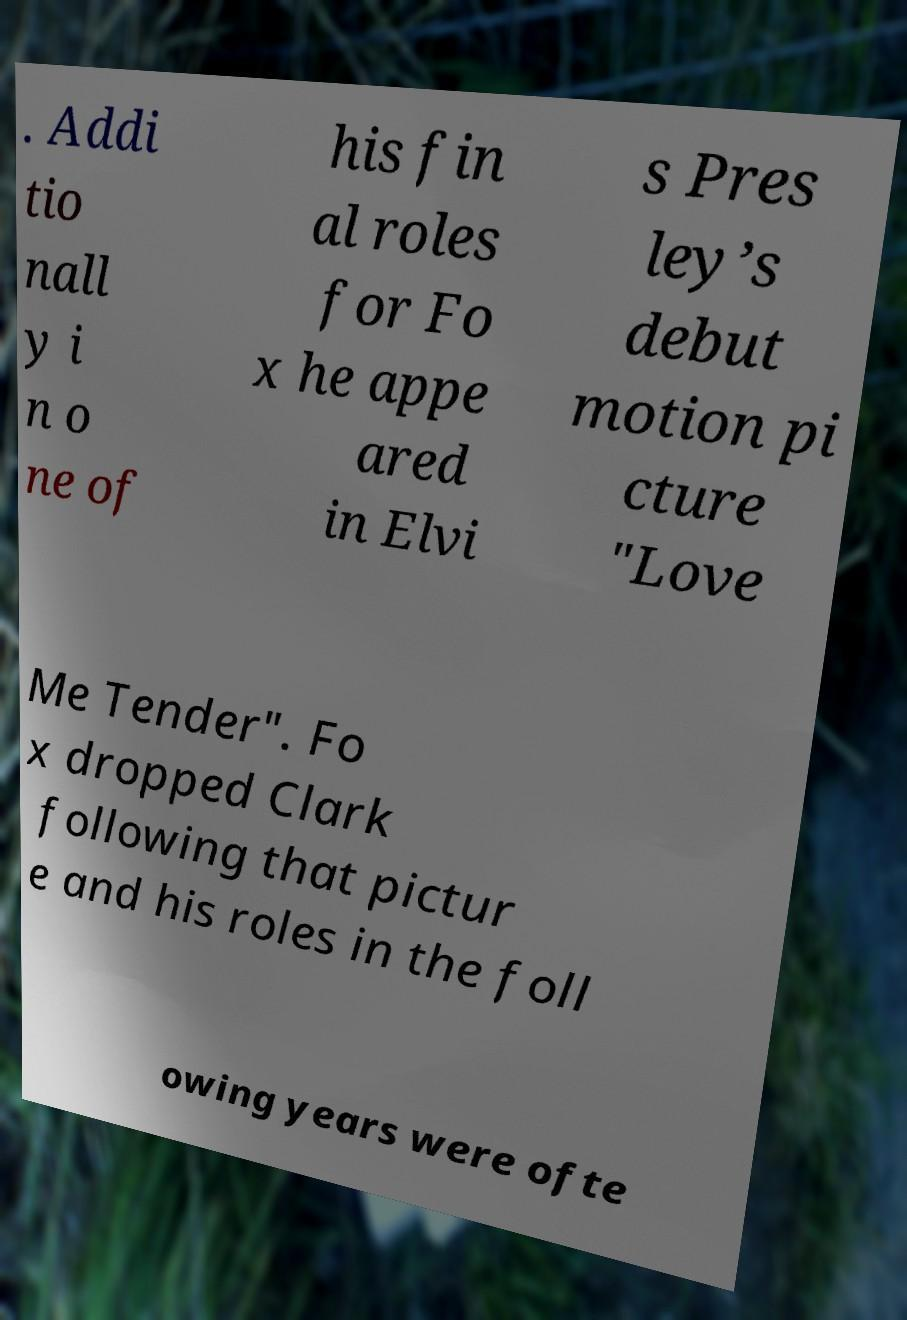Could you assist in decoding the text presented in this image and type it out clearly? . Addi tio nall y i n o ne of his fin al roles for Fo x he appe ared in Elvi s Pres ley’s debut motion pi cture "Love Me Tender". Fo x dropped Clark following that pictur e and his roles in the foll owing years were ofte 